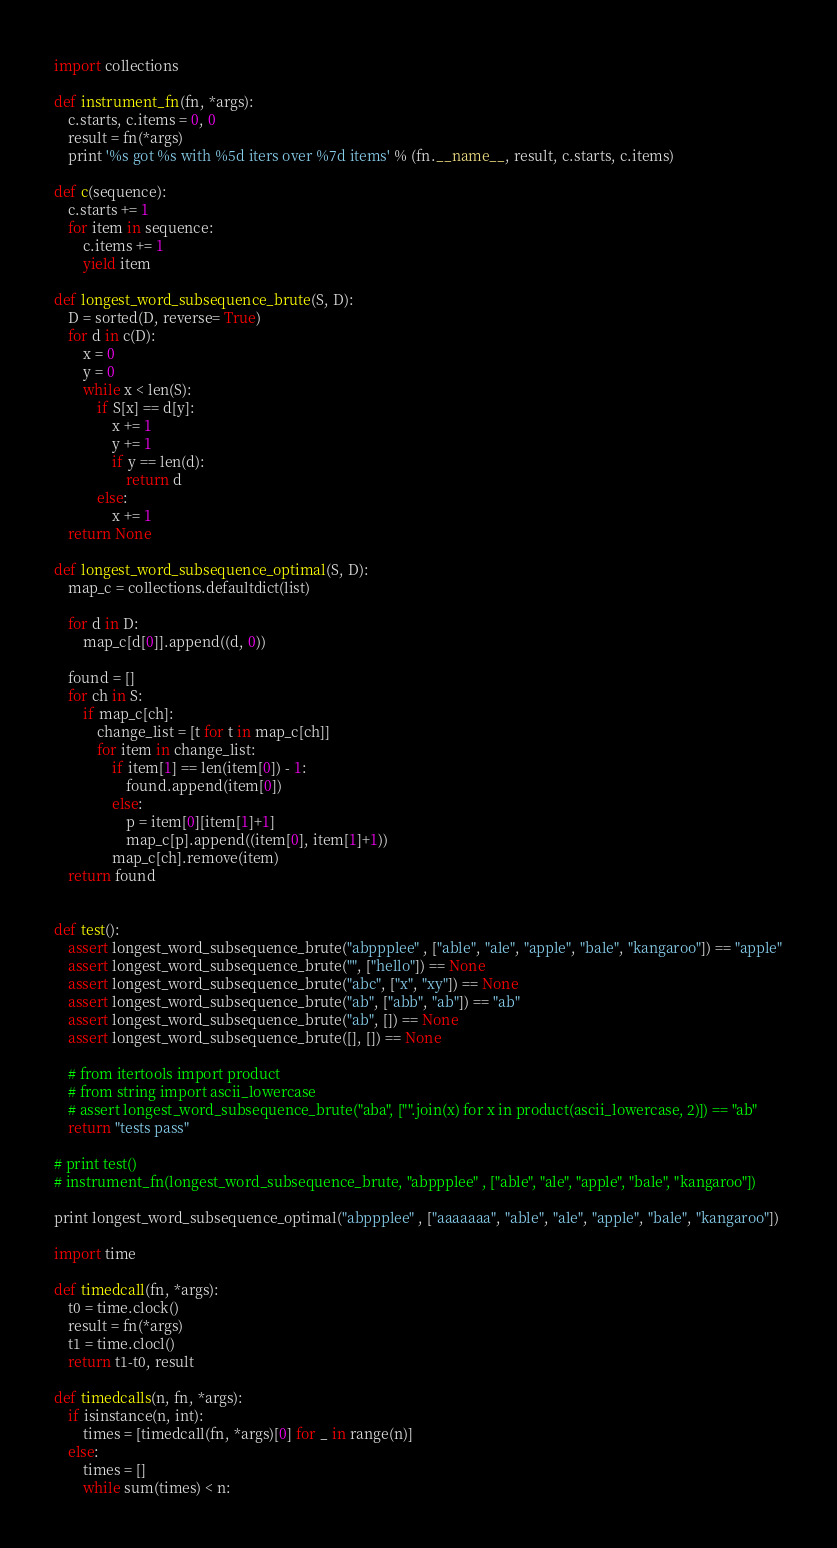Convert code to text. <code><loc_0><loc_0><loc_500><loc_500><_Python_>import collections

def instrument_fn(fn, *args):
    c.starts, c.items = 0, 0
    result = fn(*args)
    print '%s got %s with %5d iters over %7d items' % (fn.__name__, result, c.starts, c.items)

def c(sequence):
    c.starts += 1
    for item in sequence:
        c.items += 1
        yield item

def longest_word_subsequence_brute(S, D):
    D = sorted(D, reverse= True)
    for d in c(D):
        x = 0
        y = 0
        while x < len(S):
            if S[x] == d[y]:
                x += 1
                y += 1
                if y == len(d):
                    return d
            else:
                x += 1
    return None

def longest_word_subsequence_optimal(S, D):
    map_c = collections.defaultdict(list)

    for d in D:
        map_c[d[0]].append((d, 0))    

    found = []
    for ch in S:
        if map_c[ch]:
            change_list = [t for t in map_c[ch]]
            for item in change_list:
                if item[1] == len(item[0]) - 1:
                    found.append(item[0])
                else:
                    p = item[0][item[1]+1]
                    map_c[p].append((item[0], item[1]+1))
                map_c[ch].remove(item)    
    return found
         

def test():
    assert longest_word_subsequence_brute("abppplee" , ["able", "ale", "apple", "bale", "kangaroo"]) == "apple"
    assert longest_word_subsequence_brute("", ["hello"]) == None
    assert longest_word_subsequence_brute("abc", ["x", "xy"]) == None
    assert longest_word_subsequence_brute("ab", ["abb", "ab"]) == "ab"
    assert longest_word_subsequence_brute("ab", []) == None
    assert longest_word_subsequence_brute([], []) == None

    # from itertools import product
    # from string import ascii_lowercase
    # assert longest_word_subsequence_brute("aba", ["".join(x) for x in product(ascii_lowercase, 2)]) == "ab" 
    return "tests pass"

# print test()
# instrument_fn(longest_word_subsequence_brute, "abppplee" , ["able", "ale", "apple", "bale", "kangaroo"]) 

print longest_word_subsequence_optimal("abppplee" , ["aaaaaaa", "able", "ale", "apple", "bale", "kangaroo"]) 

import time

def timedcall(fn, *args):
    t0 = time.clock()
    result = fn(*args)
    t1 = time.clocl()
    return t1-t0, result

def timedcalls(n, fn, *args):
    if isinstance(n, int):
        times = [timedcall(fn, *args)[0] for _ in range(n)]
    else:
        times = []
        while sum(times) < n:</code> 